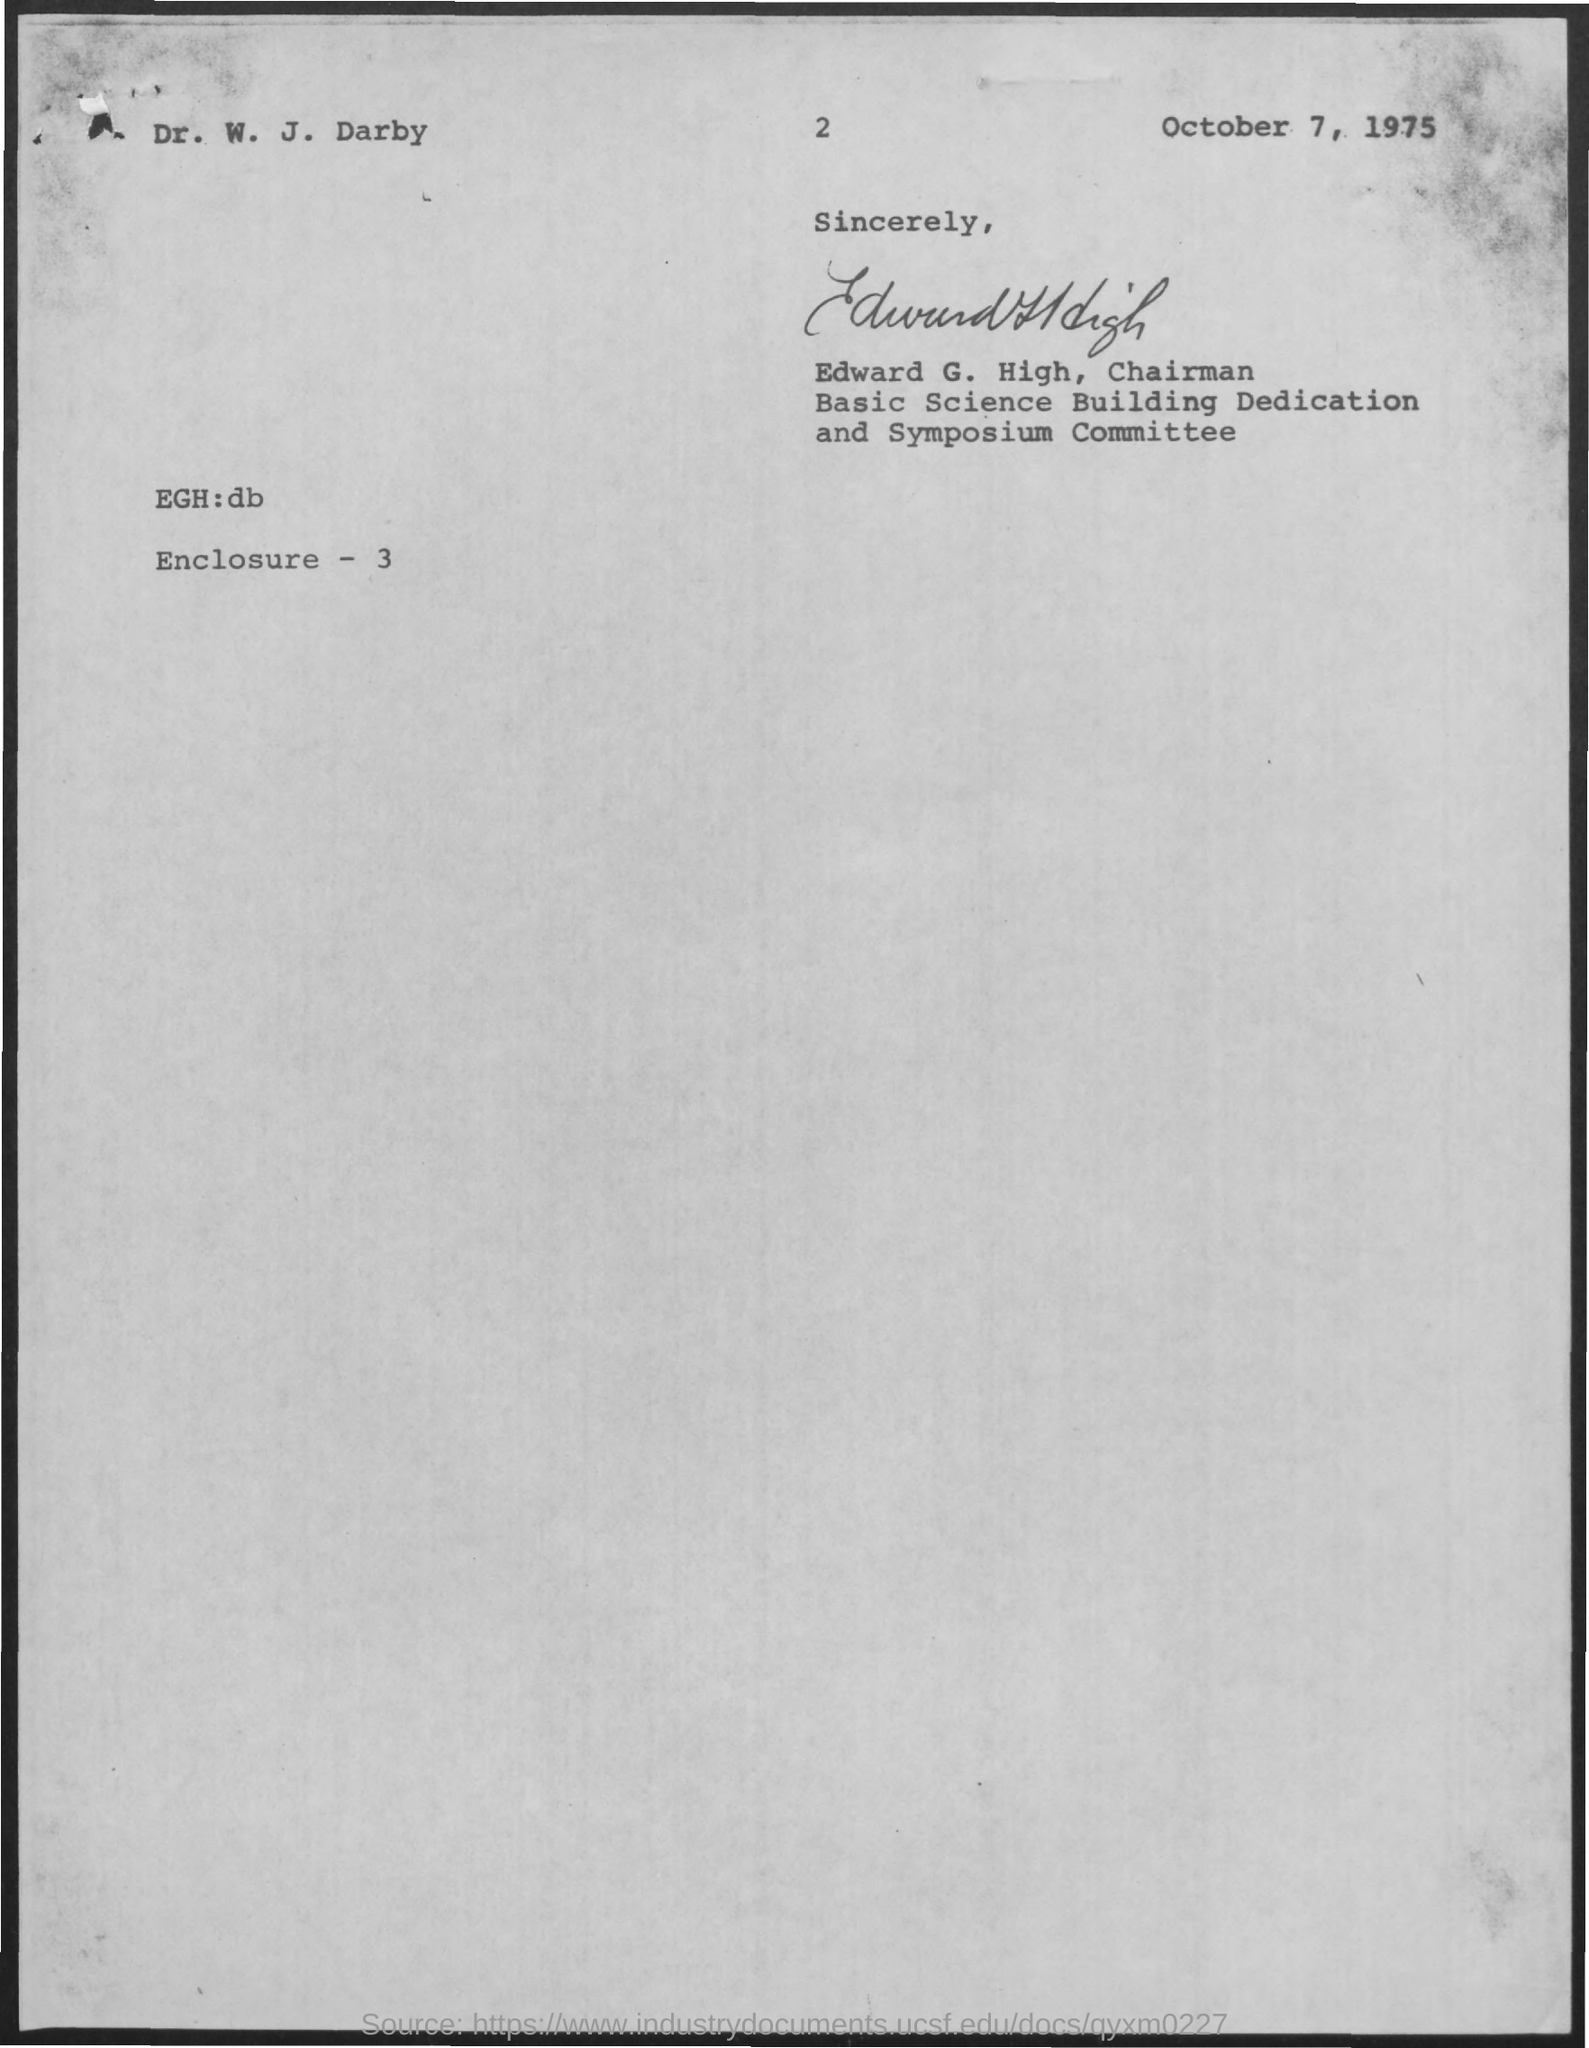Who has signed this letter?
Keep it short and to the point. Edward G. High. What is the letter dated?
Your response must be concise. October 7, 1975. 